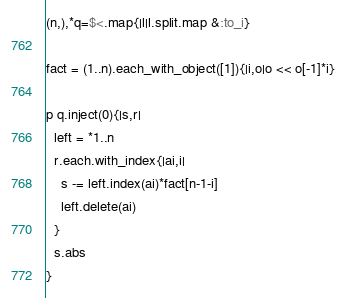Convert code to text. <code><loc_0><loc_0><loc_500><loc_500><_Ruby_>(n,),*q=$<.map{|l|l.split.map &:to_i}

fact = (1..n).each_with_object([1]){|i,o|o << o[-1]*i}

p q.inject(0){|s,r|
  left = *1..n
  r.each.with_index{|ai,i|
    s -= left.index(ai)*fact[n-1-i]
    left.delete(ai)
  }
  s.abs
}
</code> 